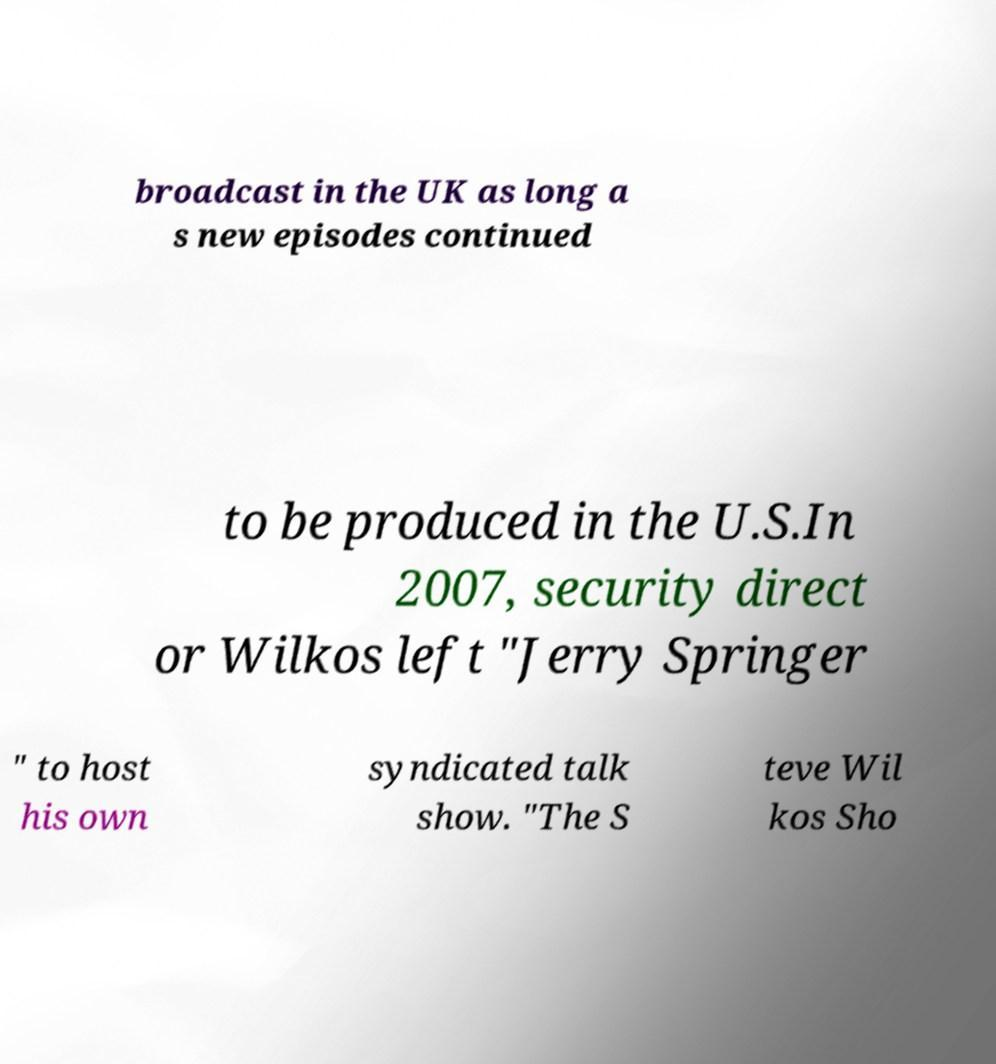Could you assist in decoding the text presented in this image and type it out clearly? broadcast in the UK as long a s new episodes continued to be produced in the U.S.In 2007, security direct or Wilkos left "Jerry Springer " to host his own syndicated talk show. "The S teve Wil kos Sho 